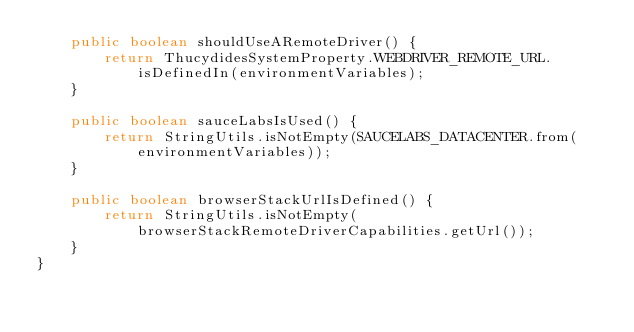<code> <loc_0><loc_0><loc_500><loc_500><_Java_>    public boolean shouldUseARemoteDriver() {
        return ThucydidesSystemProperty.WEBDRIVER_REMOTE_URL.isDefinedIn(environmentVariables);
    }

    public boolean sauceLabsIsUsed() {
        return StringUtils.isNotEmpty(SAUCELABS_DATACENTER.from(environmentVariables));
    }

    public boolean browserStackUrlIsDefined() {
        return StringUtils.isNotEmpty(browserStackRemoteDriverCapabilities.getUrl());
    }
}
</code> 